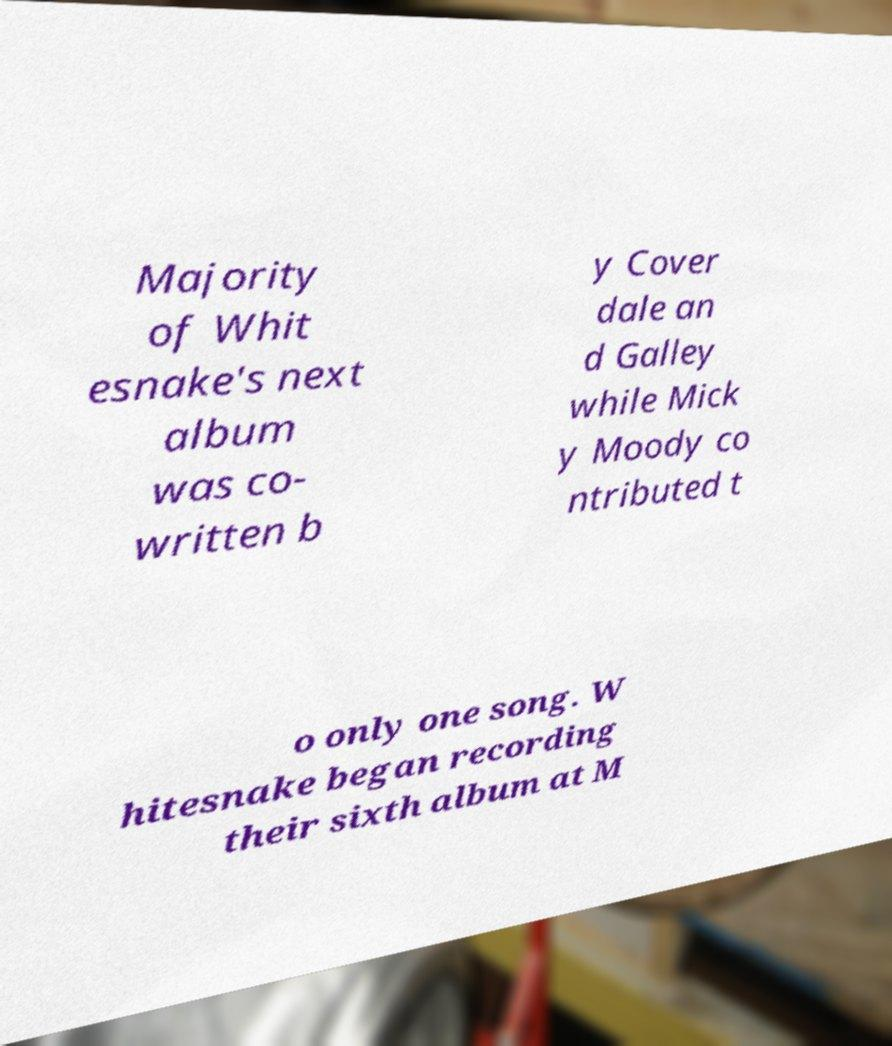Could you assist in decoding the text presented in this image and type it out clearly? Majority of Whit esnake's next album was co- written b y Cover dale an d Galley while Mick y Moody co ntributed t o only one song. W hitesnake began recording their sixth album at M 